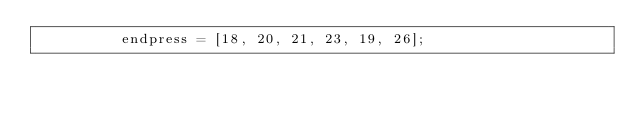<code> <loc_0><loc_0><loc_500><loc_500><_Haxe_>					endpress = [18, 20, 21, 23, 19, 26];</code> 